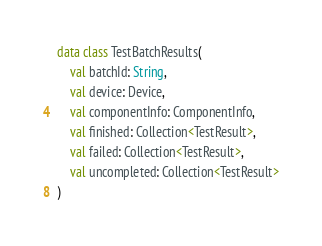<code> <loc_0><loc_0><loc_500><loc_500><_Kotlin_>
data class TestBatchResults(
    val batchId: String,
    val device: Device,
    val componentInfo: ComponentInfo,
    val finished: Collection<TestResult>,
    val failed: Collection<TestResult>,
    val uncompleted: Collection<TestResult>
)
</code> 